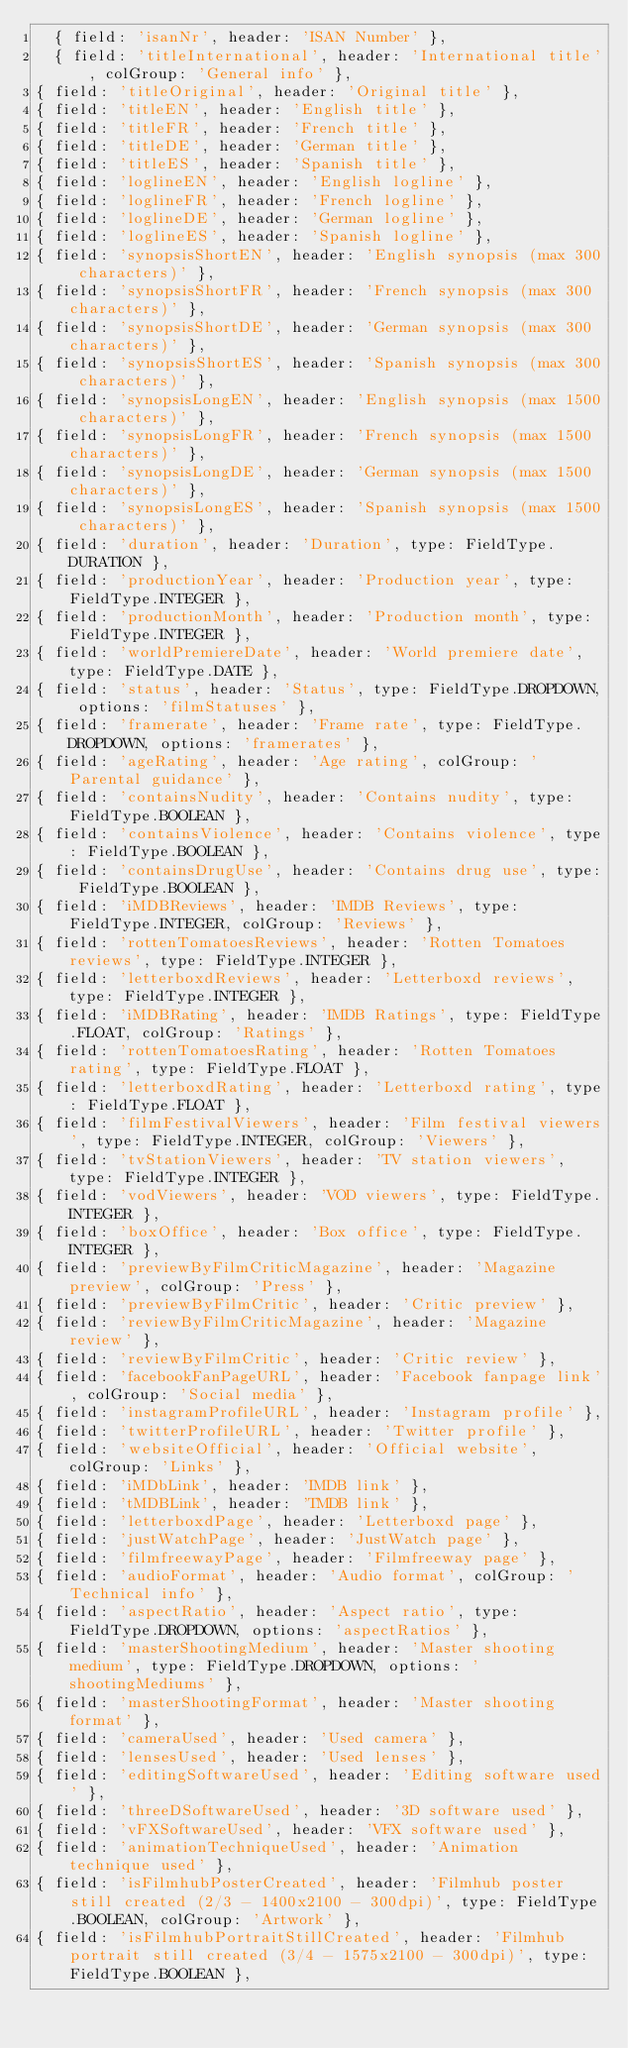Convert code to text. <code><loc_0><loc_0><loc_500><loc_500><_JavaScript_>  { field: 'isanNr', header: 'ISAN Number' },
  { field: 'titleInternational', header: 'International title', colGroup: 'General info' },
{ field: 'titleOriginal', header: 'Original title' },
{ field: 'titleEN', header: 'English title' },
{ field: 'titleFR', header: 'French title' },
{ field: 'titleDE', header: 'German title' },
{ field: 'titleES', header: 'Spanish title' },
{ field: 'loglineEN', header: 'English logline' },
{ field: 'loglineFR', header: 'French logline' },
{ field: 'loglineDE', header: 'German logline' },
{ field: 'loglineES', header: 'Spanish logline' },
{ field: 'synopsisShortEN', header: 'English synopsis (max 300 characters)' },
{ field: 'synopsisShortFR', header: 'French synopsis (max 300 characters)' },
{ field: 'synopsisShortDE', header: 'German synopsis (max 300 characters)' },
{ field: 'synopsisShortES', header: 'Spanish synopsis (max 300 characters)' },
{ field: 'synopsisLongEN', header: 'English synopsis (max 1500 characters)' },
{ field: 'synopsisLongFR', header: 'French synopsis (max 1500 characters)' },
{ field: 'synopsisLongDE', header: 'German synopsis (max 1500 characters)' },
{ field: 'synopsisLongES', header: 'Spanish synopsis (max 1500 characters)' },
{ field: 'duration', header: 'Duration', type: FieldType.DURATION },
{ field: 'productionYear', header: 'Production year', type: FieldType.INTEGER },
{ field: 'productionMonth', header: 'Production month', type: FieldType.INTEGER },
{ field: 'worldPremiereDate', header: 'World premiere date', type: FieldType.DATE },
{ field: 'status', header: 'Status', type: FieldType.DROPDOWN, options: 'filmStatuses' },
{ field: 'framerate', header: 'Frame rate', type: FieldType.DROPDOWN, options: 'framerates' },
{ field: 'ageRating', header: 'Age rating', colGroup: 'Parental guidance' },
{ field: 'containsNudity', header: 'Contains nudity', type: FieldType.BOOLEAN },
{ field: 'containsViolence', header: 'Contains violence', type: FieldType.BOOLEAN },
{ field: 'containsDrugUse', header: 'Contains drug use', type: FieldType.BOOLEAN },
{ field: 'iMDBReviews', header: 'IMDB Reviews', type: FieldType.INTEGER, colGroup: 'Reviews' },
{ field: 'rottenTomatoesReviews', header: 'Rotten Tomatoes reviews', type: FieldType.INTEGER },
{ field: 'letterboxdReviews', header: 'Letterboxd reviews', type: FieldType.INTEGER },
{ field: 'iMDBRating', header: 'IMDB Ratings', type: FieldType.FLOAT, colGroup: 'Ratings' },
{ field: 'rottenTomatoesRating', header: 'Rotten Tomatoes rating', type: FieldType.FLOAT },
{ field: 'letterboxdRating', header: 'Letterboxd rating', type: FieldType.FLOAT },
{ field: 'filmFestivalViewers', header: 'Film festival viewers', type: FieldType.INTEGER, colGroup: 'Viewers' },
{ field: 'tvStationViewers', header: 'TV station viewers', type: FieldType.INTEGER },
{ field: 'vodViewers', header: 'VOD viewers', type: FieldType.INTEGER },
{ field: 'boxOffice', header: 'Box office', type: FieldType.INTEGER },
{ field: 'previewByFilmCriticMagazine', header: 'Magazine preview', colGroup: 'Press' },
{ field: 'previewByFilmCritic', header: 'Critic preview' },
{ field: 'reviewByFilmCriticMagazine', header: 'Magazine review' },
{ field: 'reviewByFilmCritic', header: 'Critic review' },
{ field: 'facebookFanPageURL', header: 'Facebook fanpage link', colGroup: 'Social media' },
{ field: 'instagramProfileURL', header: 'Instagram profile' },
{ field: 'twitterProfileURL', header: 'Twitter profile' },
{ field: 'websiteOfficial', header: 'Official website', colGroup: 'Links' },
{ field: 'iMDbLink', header: 'IMDB link' },
{ field: 'tMDBLink', header: 'TMDB link' },
{ field: 'letterboxdPage', header: 'Letterboxd page' },
{ field: 'justWatchPage', header: 'JustWatch page' },
{ field: 'filmfreewayPage', header: 'Filmfreeway page' },
{ field: 'audioFormat', header: 'Audio format', colGroup: 'Technical info' },
{ field: 'aspectRatio', header: 'Aspect ratio', type: FieldType.DROPDOWN, options: 'aspectRatios' },
{ field: 'masterShootingMedium', header: 'Master shooting medium', type: FieldType.DROPDOWN, options: 'shootingMediums' },
{ field: 'masterShootingFormat', header: 'Master shooting format' },
{ field: 'cameraUsed', header: 'Used camera' },
{ field: 'lensesUsed', header: 'Used lenses' },
{ field: 'editingSoftwareUsed', header: 'Editing software used' },
{ field: 'threeDSoftwareUsed', header: '3D software used' },
{ field: 'vFXSoftwareUsed', header: 'VFX software used' },
{ field: 'animationTechniqueUsed', header: 'Animation technique used' },
{ field: 'isFilmhubPosterCreated', header: 'Filmhub poster still created (2/3 - 1400x2100 - 300dpi)', type: FieldType.BOOLEAN, colGroup: 'Artwork' },
{ field: 'isFilmhubPortraitStillCreated', header: 'Filmhub portrait still created (3/4 - 1575x2100 - 300dpi)', type: FieldType.BOOLEAN },</code> 